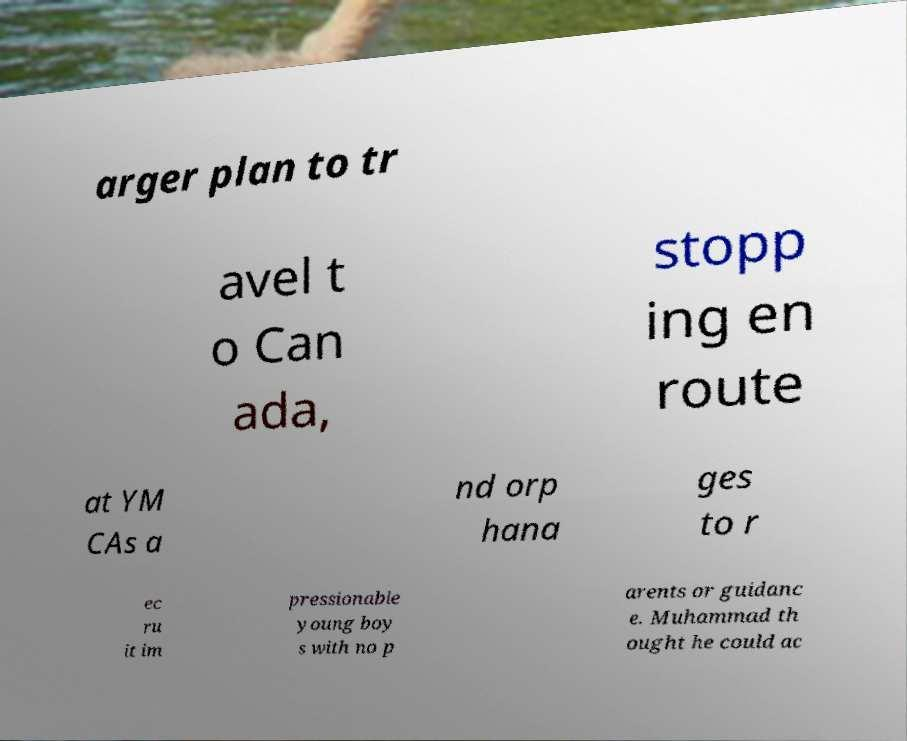Could you assist in decoding the text presented in this image and type it out clearly? arger plan to tr avel t o Can ada, stopp ing en route at YM CAs a nd orp hana ges to r ec ru it im pressionable young boy s with no p arents or guidanc e. Muhammad th ought he could ac 